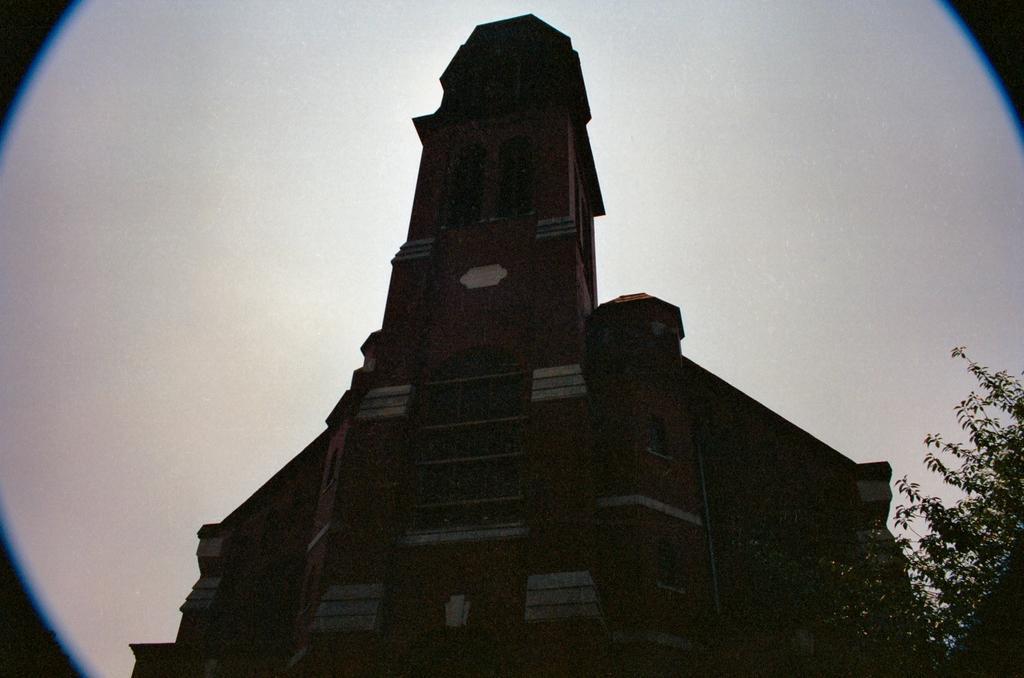Could you give a brief overview of what you see in this image? There is a building with windows. In the background it is white. In the right bottom corner there is a tree. 